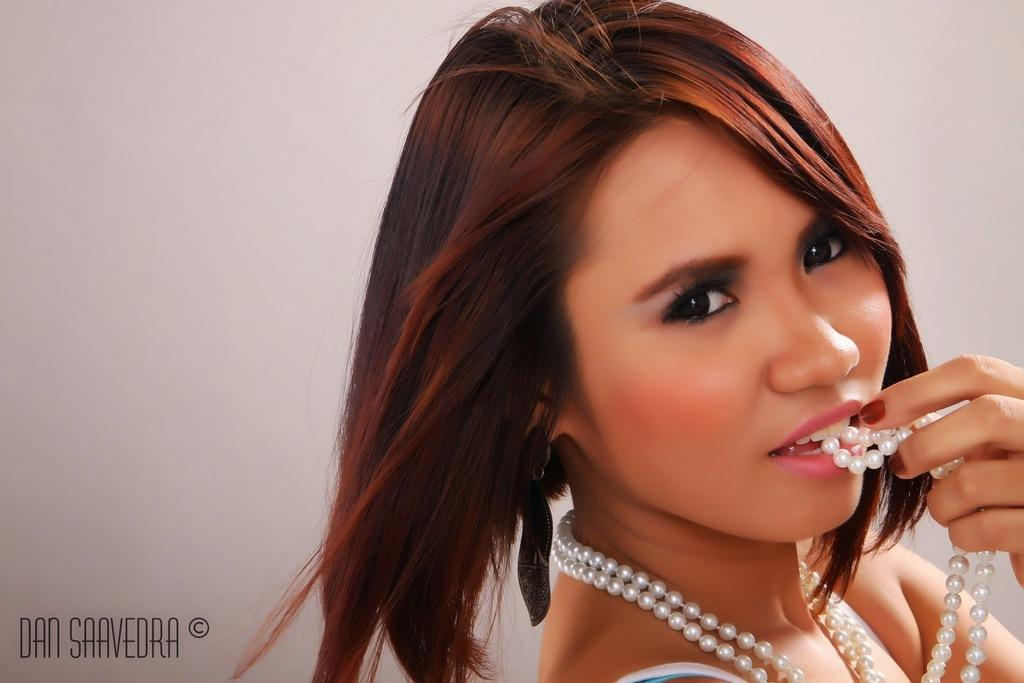Who is the main subject in the image? There is a woman in the image. What is the woman doing in the image? The woman is standing in the image. What accessory is the woman wearing? The woman is wearing a pearl necklace. How is the woman interacting with the pearl necklace? The woman is holding the pearl necklace with her hand and keeping it in her mouth. What thing is causing the woman to slip in the image? There is no indication in the image that the woman is slipping or that any object is causing her to slip. 